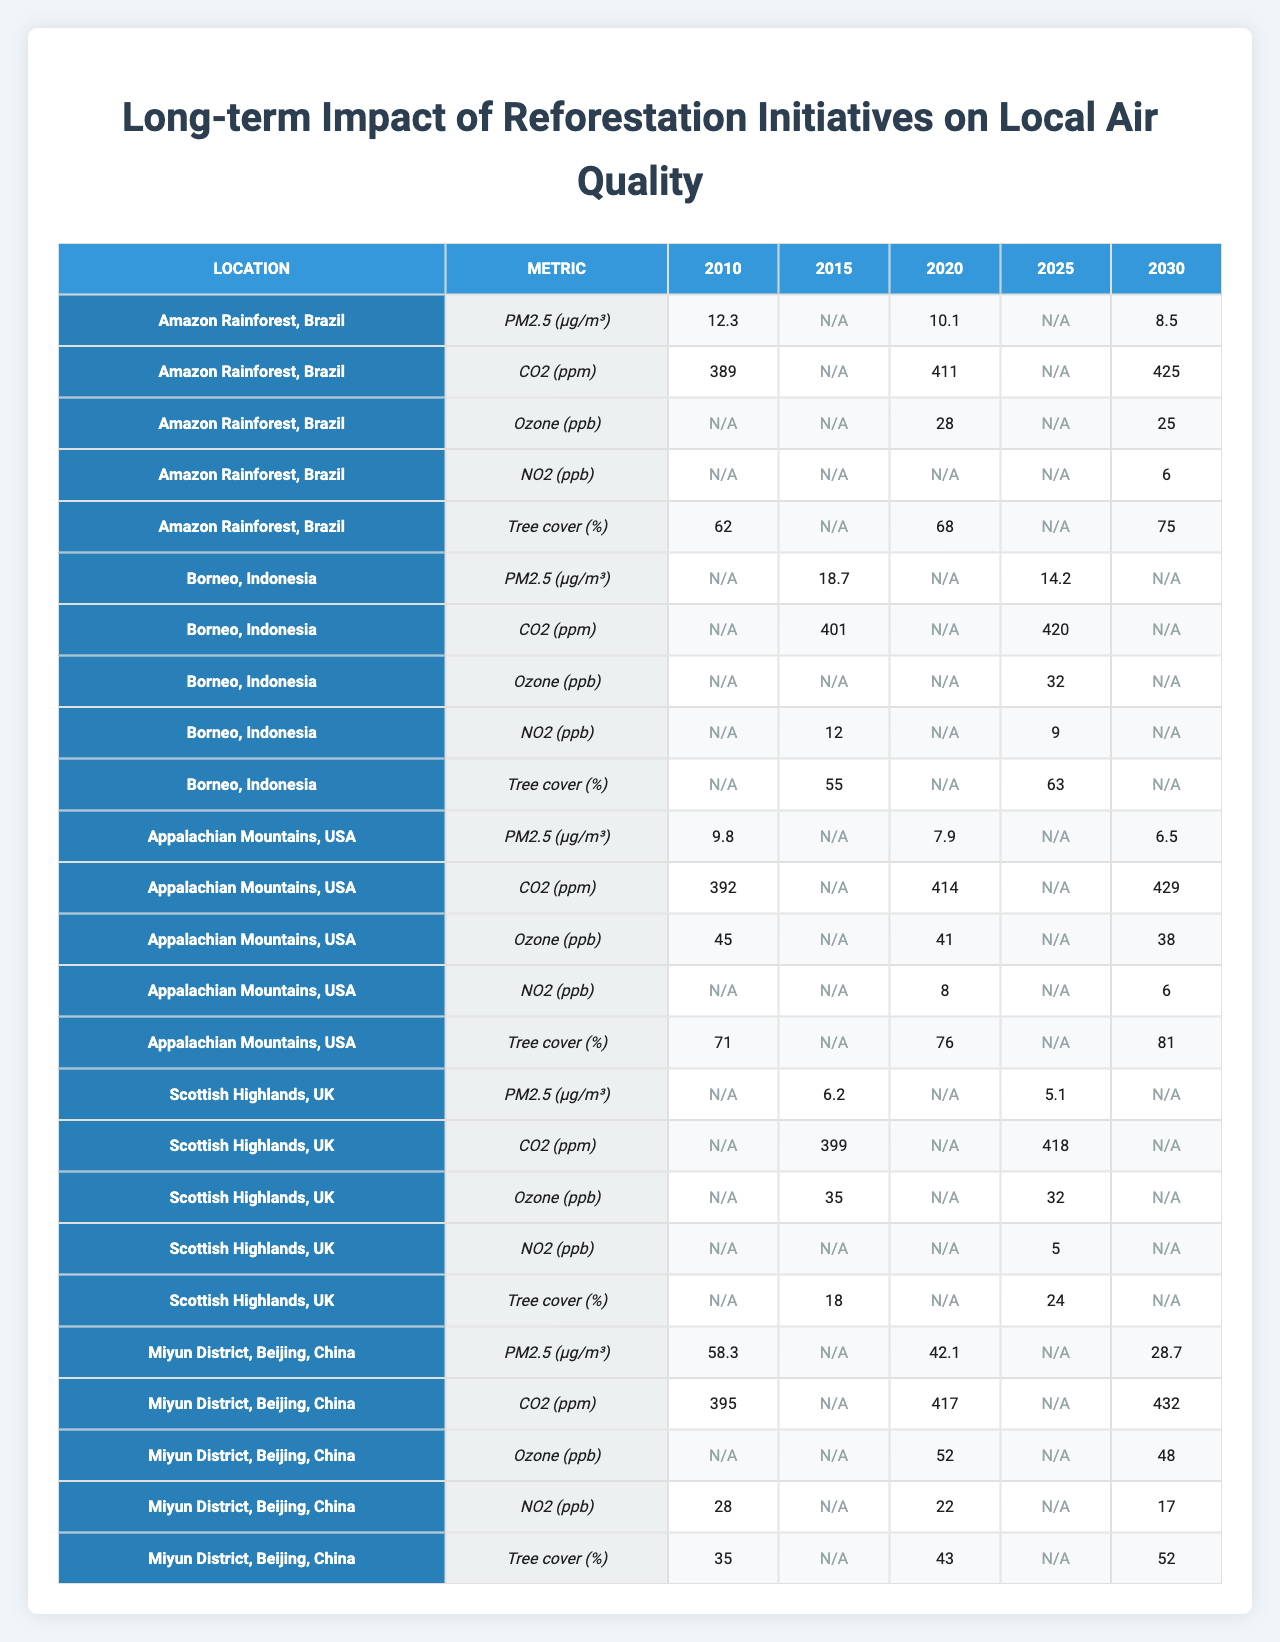What was the PM2.5 level in the Amazon Rainforest in 2010? The table shows that the PM2.5 level in the Amazon Rainforest in 2010 is 12.3 μg/m³.
Answer: 12.3 μg/m³ What was the highest recorded CO2 level in Borneo, Indonesia from the data provided? In the table, the CO2 levels in Borneo are 401 ppm in 2015 and 420 ppm in 2025. The highest value is 420 ppm in 2025.
Answer: 420 ppm What was the percentage increase in tree cover from 2010 to 2030 in the Appalachian Mountains? The tree cover in the Appalachian Mountains increased from 71% in 2010 to 81% in 2030. The increase is 81% - 71% = 10%.
Answer: 10% Was there a decrease in PM2.5 levels from 2010 to 2020 in the Scottish Highlands? In the Scottish Highlands, PM2.5 was 6.2 μg/m³ in 2015 and is not available for 2010 but was less than 6.2 μg/m³, indicating a decrease.
Answer: Yes What is the average Ozone level recorded in Miyun District, Beijing for the years 2020 and 2030? The Ozone levels in Miyun District are 52 ppb in 2020 and 48 ppb in 2030. The average is (52 + 48) / 2 = 50 ppb.
Answer: 50 ppb How much did NO2 levels change between 2015 and 2025 in Borneo, Indonesia? In Borneo, NO2 levels decreased from 12 ppb in 2015 to 9 ppb in 2025, resulting in a change of 12 - 9 = 3 ppb.
Answer: 3 ppb Which location had the lowest reported PM2.5 level in 2020? The table indicates that the lowest PM2.5 level in 2020 was in the Appalachian Mountains at 7.9 μg/m³.
Answer: Appalachian Mountains Was the tree cover in the Scottish Highlands greater in 2025 than in 2015? The table shows that tree cover in the Scottish Highlands increased from 18% in 2015 to 24% in 2025, which confirms the statement.
Answer: Yes What is the difference in CO2 levels recorded in the Amazon Rainforest between 2020 and 2030? The CO2 levels in the Amazon Rainforest are 411 ppm in 2020 and 425 ppm in 2030. The difference is 425 - 411 = 14 ppm.
Answer: 14 ppm Did PM2.5 levels in the Miyun District improve from 2010 to 2030? The PM2.5 levels decreased from 58.3 μg/m³ in 2010 to 28.7 μg/m³ in 2030, indicating an improvement in air quality.
Answer: Yes 